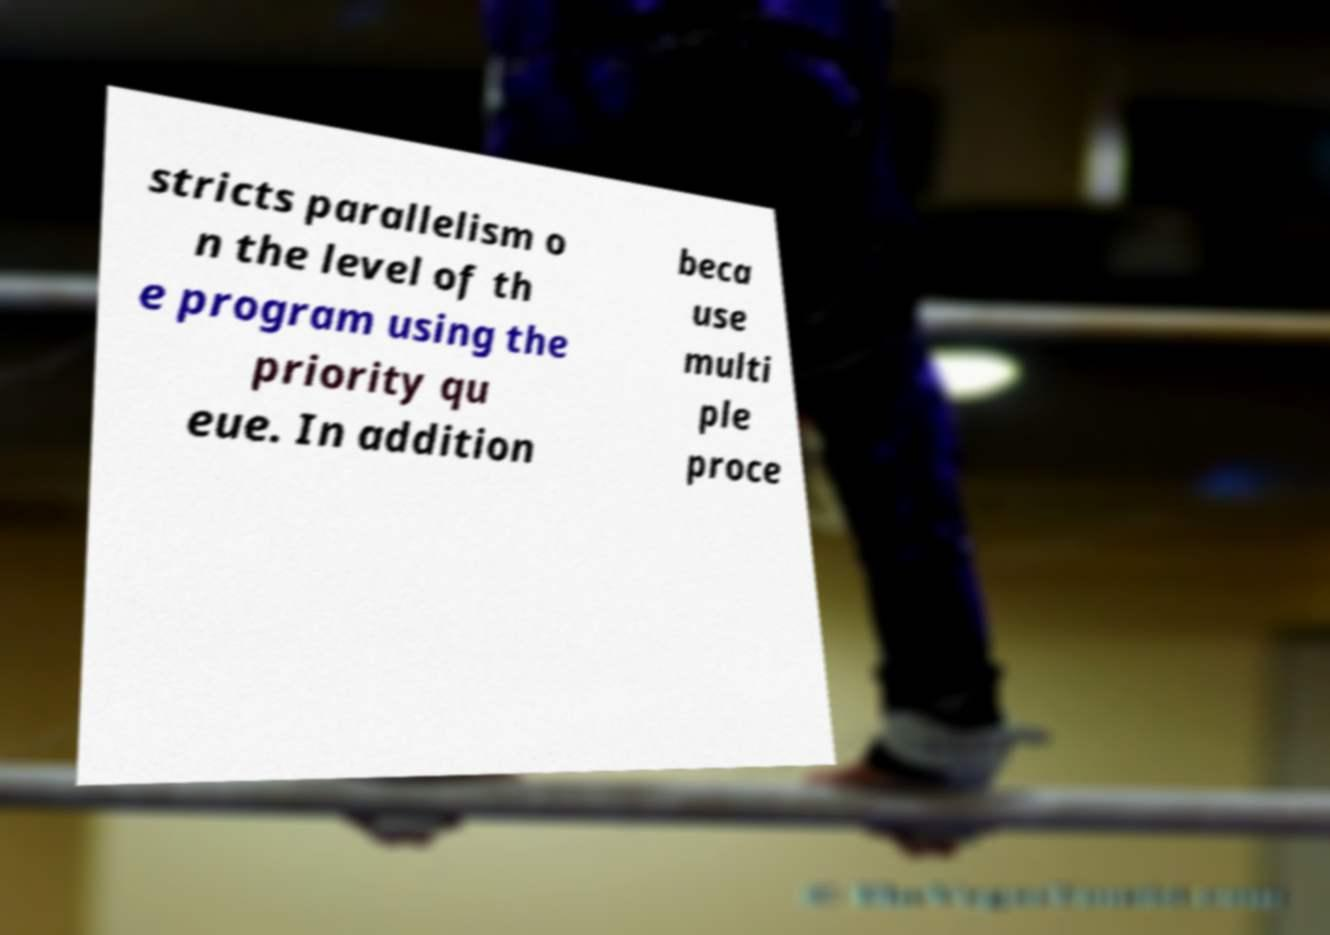There's text embedded in this image that I need extracted. Can you transcribe it verbatim? stricts parallelism o n the level of th e program using the priority qu eue. In addition beca use multi ple proce 